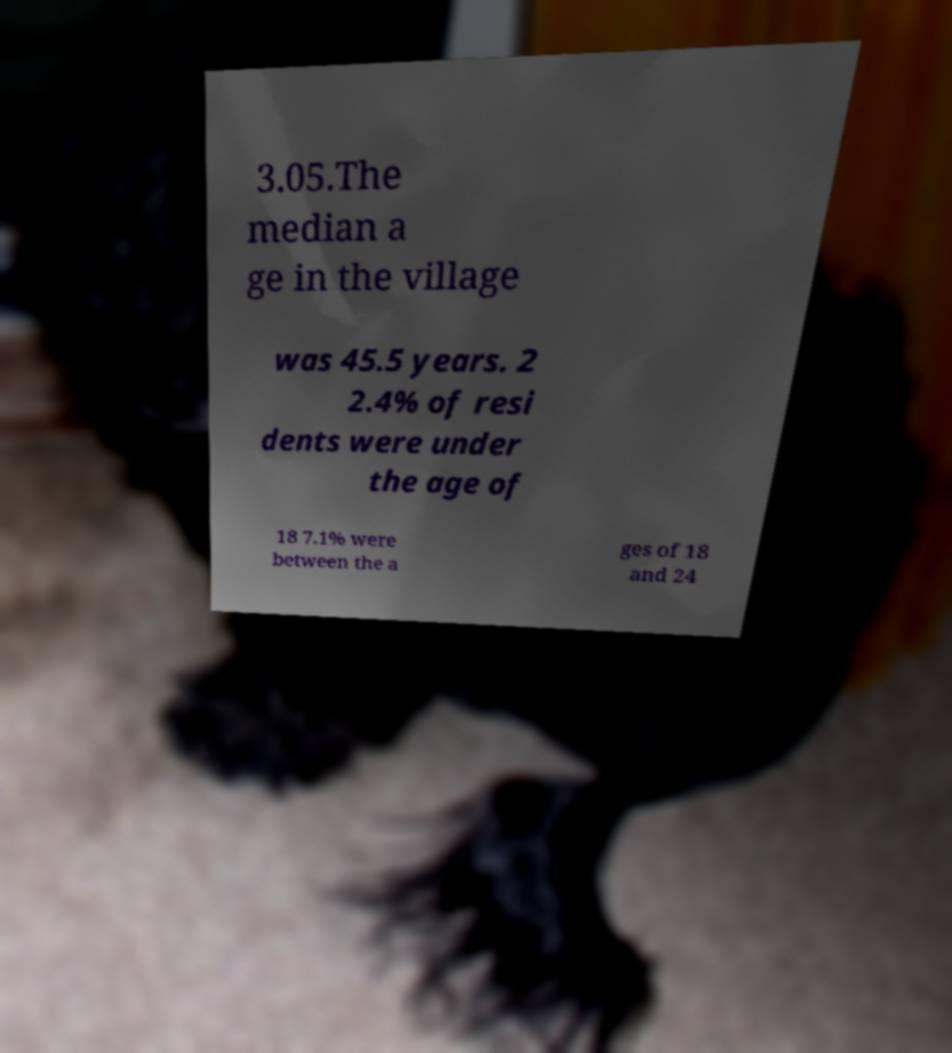I need the written content from this picture converted into text. Can you do that? 3.05.The median a ge in the village was 45.5 years. 2 2.4% of resi dents were under the age of 18 7.1% were between the a ges of 18 and 24 